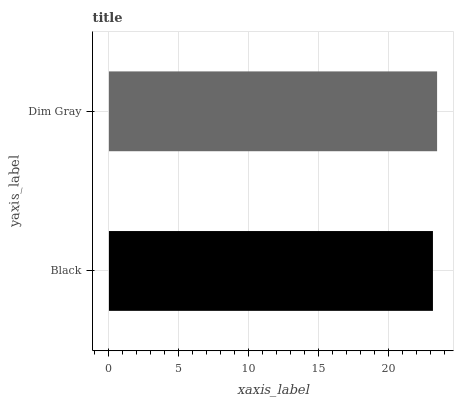Is Black the minimum?
Answer yes or no. Yes. Is Dim Gray the maximum?
Answer yes or no. Yes. Is Dim Gray the minimum?
Answer yes or no. No. Is Dim Gray greater than Black?
Answer yes or no. Yes. Is Black less than Dim Gray?
Answer yes or no. Yes. Is Black greater than Dim Gray?
Answer yes or no. No. Is Dim Gray less than Black?
Answer yes or no. No. Is Dim Gray the high median?
Answer yes or no. Yes. Is Black the low median?
Answer yes or no. Yes. Is Black the high median?
Answer yes or no. No. Is Dim Gray the low median?
Answer yes or no. No. 